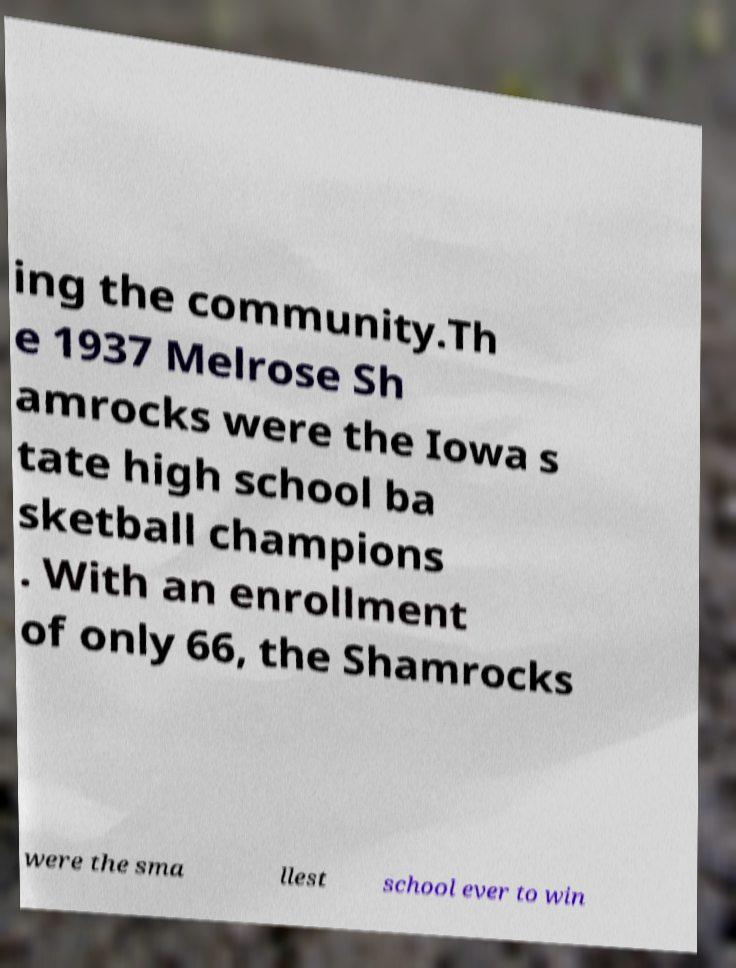There's text embedded in this image that I need extracted. Can you transcribe it verbatim? ing the community.Th e 1937 Melrose Sh amrocks were the Iowa s tate high school ba sketball champions . With an enrollment of only 66, the Shamrocks were the sma llest school ever to win 